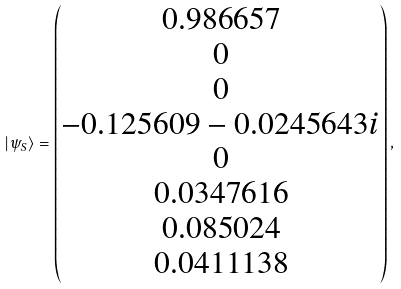<formula> <loc_0><loc_0><loc_500><loc_500>| \psi _ { S } \rangle = \begin{pmatrix} 0 . 9 8 6 6 5 7 \\ 0 \\ 0 \\ - 0 . 1 2 5 6 0 9 - 0 . 0 2 4 5 6 4 3 i \\ 0 \\ 0 . 0 3 4 7 6 1 6 \\ 0 . 0 8 5 0 2 4 \\ 0 . 0 4 1 1 1 3 8 \end{pmatrix} ,</formula> 